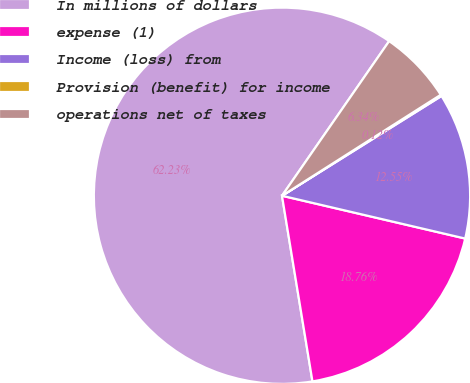Convert chart. <chart><loc_0><loc_0><loc_500><loc_500><pie_chart><fcel>In millions of dollars<fcel>expense (1)<fcel>Income (loss) from<fcel>Provision (benefit) for income<fcel>operations net of taxes<nl><fcel>62.24%<fcel>18.76%<fcel>12.55%<fcel>0.12%<fcel>6.34%<nl></chart> 